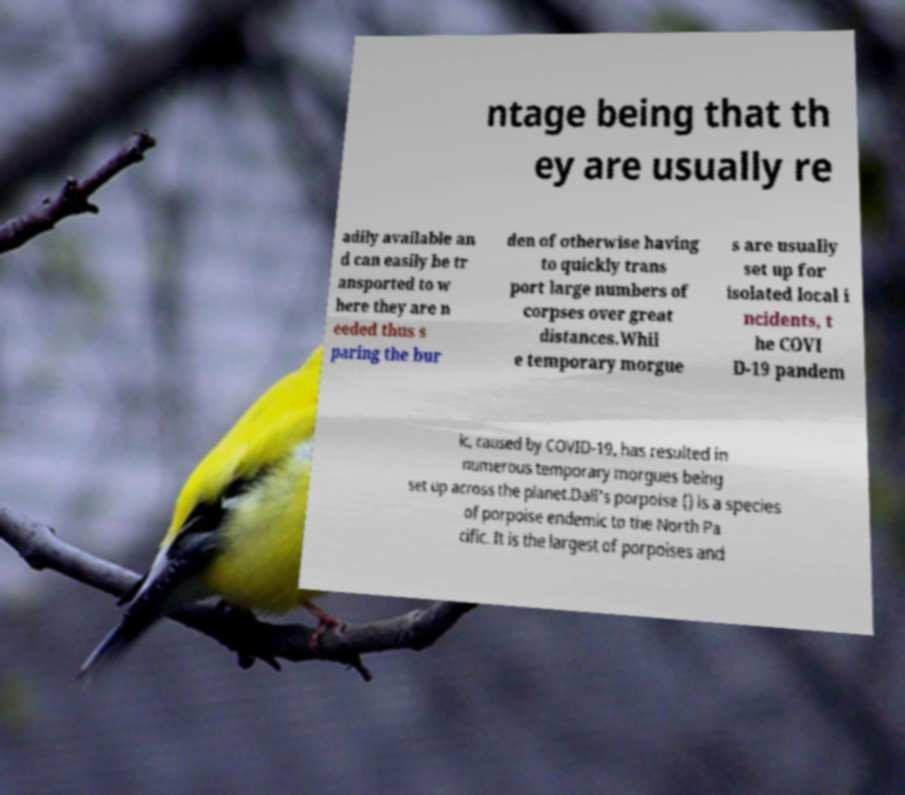Please identify and transcribe the text found in this image. ntage being that th ey are usually re adily available an d can easily be tr ansported to w here they are n eeded thus s paring the bur den of otherwise having to quickly trans port large numbers of corpses over great distances.Whil e temporary morgue s are usually set up for isolated local i ncidents, t he COVI D-19 pandem ic, caused by COVID-19, has resulted in numerous temporary morgues being set up across the planet.Dall's porpoise () is a species of porpoise endemic to the North Pa cific. It is the largest of porpoises and 